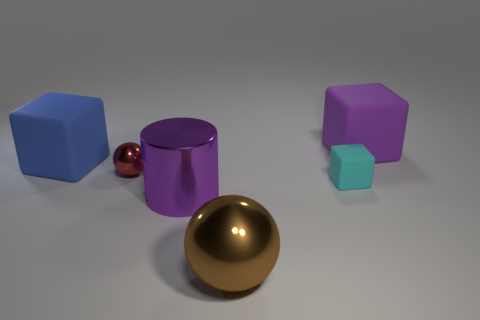Is the shiny cylinder the same size as the cyan matte cube?
Provide a short and direct response. No. There is a tiny red shiny ball; what number of metallic things are on the right side of it?
Offer a very short reply. 2. What number of things are either cubes that are on the right side of the brown ball or shiny objects?
Ensure brevity in your answer.  5. Are there more blue rubber objects on the right side of the shiny cylinder than tiny cyan objects behind the purple rubber cube?
Provide a short and direct response. No. There is a rubber object that is the same color as the big metallic cylinder; what size is it?
Provide a succinct answer. Large. Does the brown thing have the same size as the sphere that is on the left side of the big shiny sphere?
Provide a succinct answer. No. What number of spheres are either tiny purple things or metal objects?
Keep it short and to the point. 2. There is a cylinder that is made of the same material as the large brown sphere; what size is it?
Keep it short and to the point. Large. Does the ball right of the red ball have the same size as the object behind the blue matte thing?
Make the answer very short. Yes. How many things are tiny purple things or big things?
Offer a terse response. 4. 